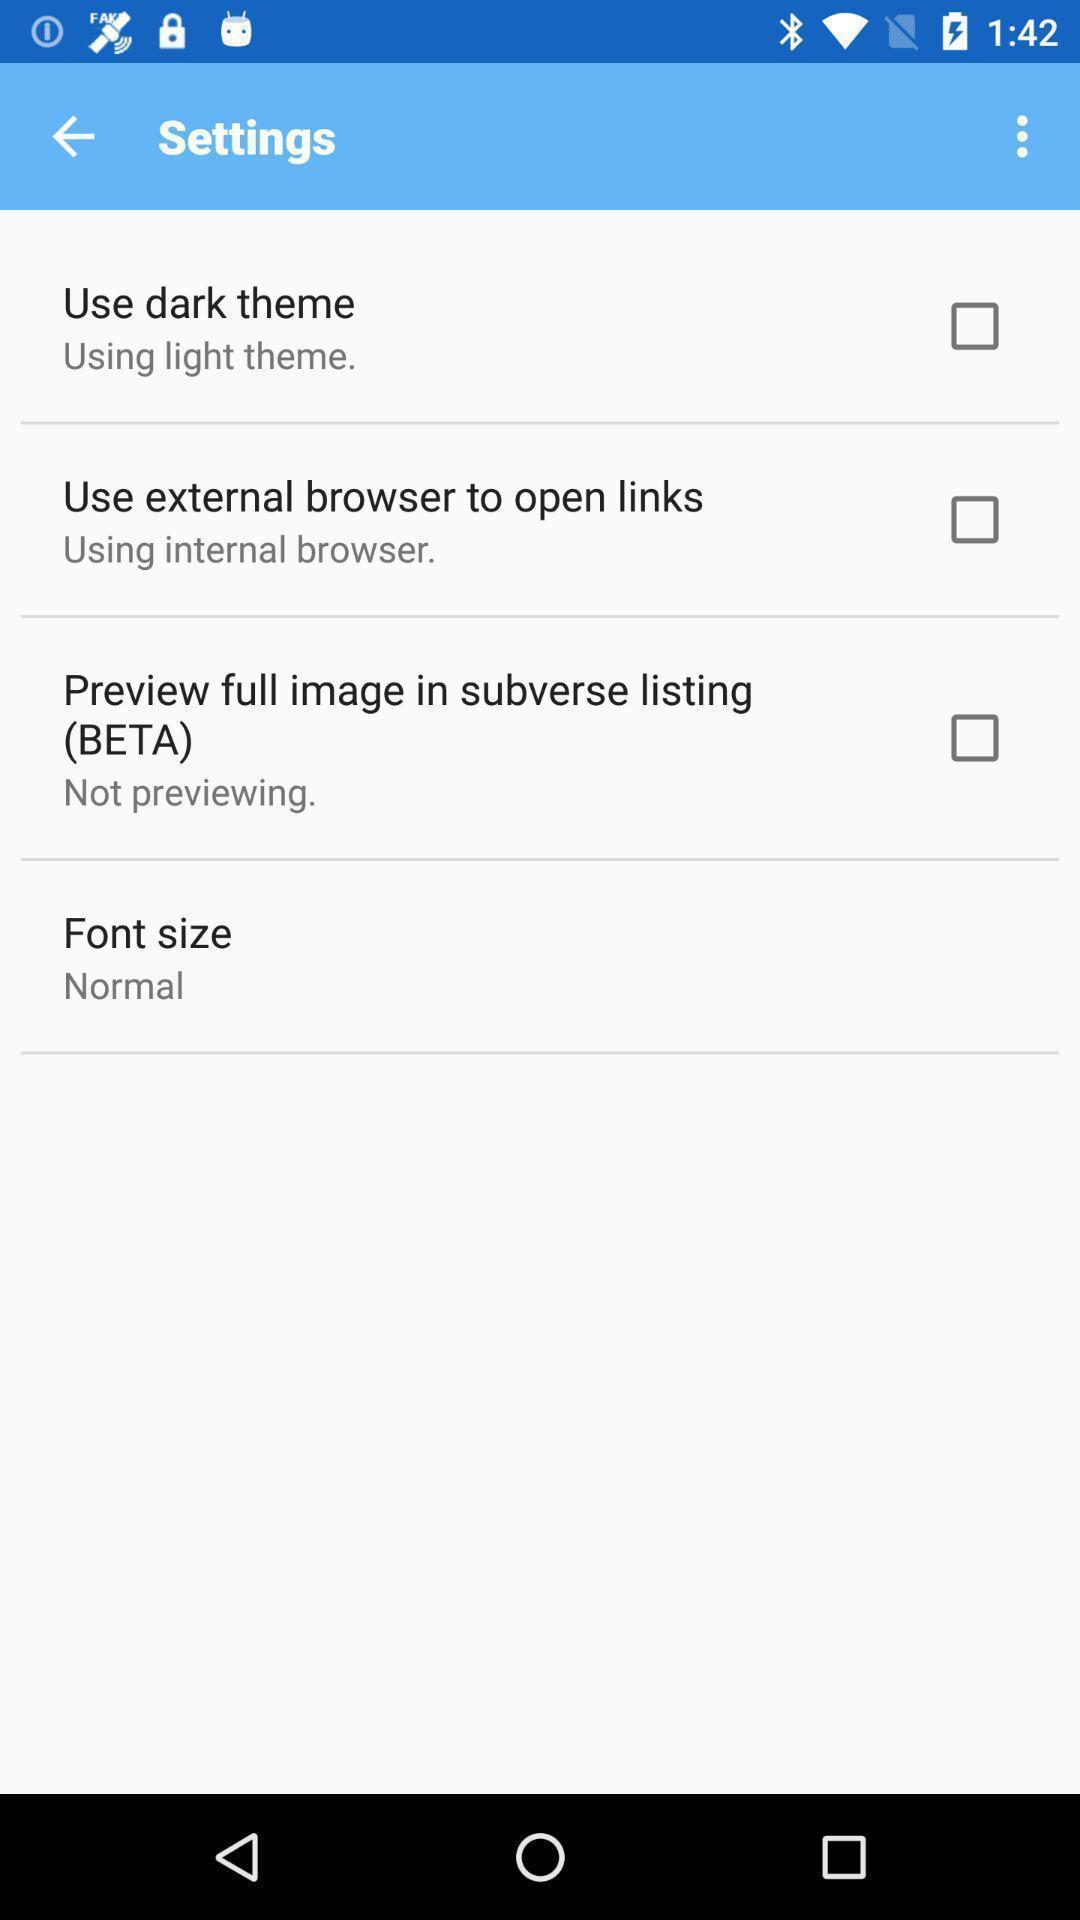What can you discern from this picture? Settings page of an online theming app. 